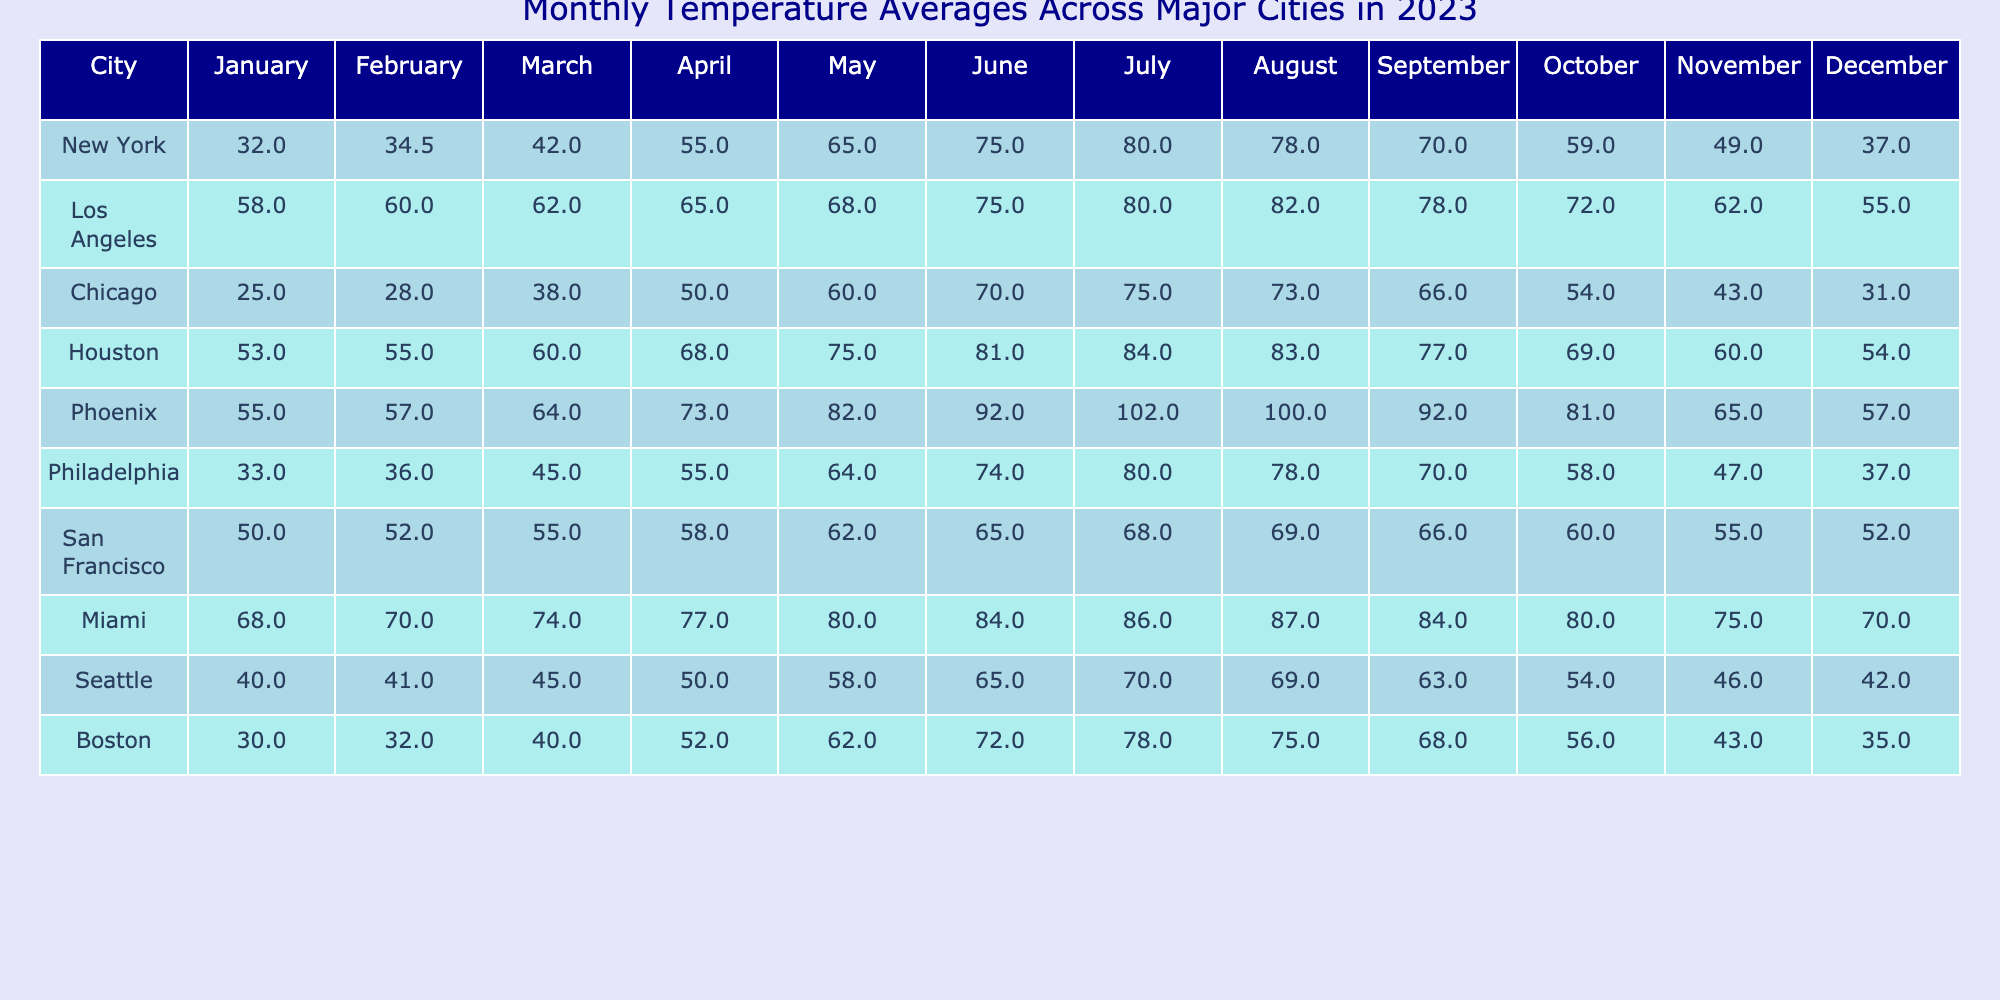What is the highest average temperature in July among these cities? Reviewing the July temperatures for all cities, we find that Phoenix has the highest average temperature of 102.0 degrees.
Answer: 102.0 Which city has the lowest average temperature in January? By examining the January temperatures, Chicago has the lowest average temperature of 25.0 degrees.
Answer: 25.0 What is the average temperature for Los Angeles in the summer months (June, July, August)? First, we sum the temperatures for June (75.0), July (80.0), and August (82.0): 75.0 + 80.0 + 82.0 = 237.0. Then we divide by 3 for the average: 237.0 / 3 = 79.0 degrees.
Answer: 79.0 Is Miami's average temperature in December higher than New York's in the same month? In December, Miami's temperature is 70.0 degrees, while New York's is 37.0 degrees. Therefore, Miami's temperature is higher.
Answer: Yes What is the median temperature for February across all cities? First, we list the February temperatures in order: 28.0 (Chicago), 34.5 (New York), 36.0 (Philadelphia), 41.0 (Seattle), 52.0 (San Francisco), 55.0 (Houston), 57.0 (Phoenix), 60.0 (Los Angeles), 70.0 (Miami). The median, being the average of the 5th and 6th values (52.0 and 55.0), is (52.0 + 55.0) / 2 = 53.5 degrees.
Answer: 53.5 Which city has a consistent temperature pattern, with relatively small variations throughout the year? Analyzing the data, San Francisco has the smallest temperature range, varying from 50.0 to 69.0 degrees.
Answer: San Francisco What is the sum of temperatures in March across all cities? We add the March temperatures: 42.0 (New York) + 62.0 (Los Angeles) + 38.0 (Chicago) + 60.0 (Houston) + 64.0 (Phoenix) + 45.0 (Philadelphia) + 55.0 (San Francisco) + 74.0 (Miami) + 45.0 (Seattle) + 40.0 (Boston) =  626.0 degrees.
Answer: 626.0 